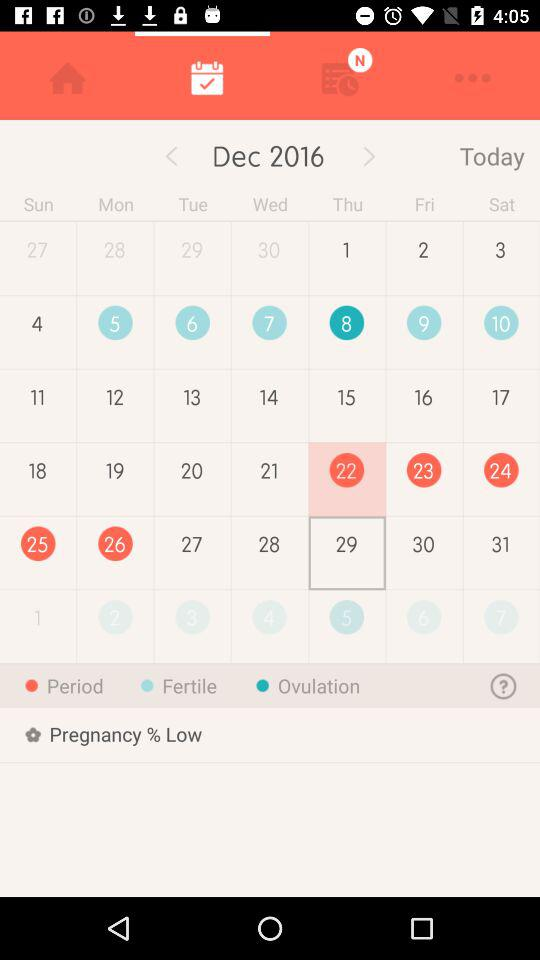What are the fertile dates? The fertile dates are December 5th, 6th, 7th, 9th, and 10th. 